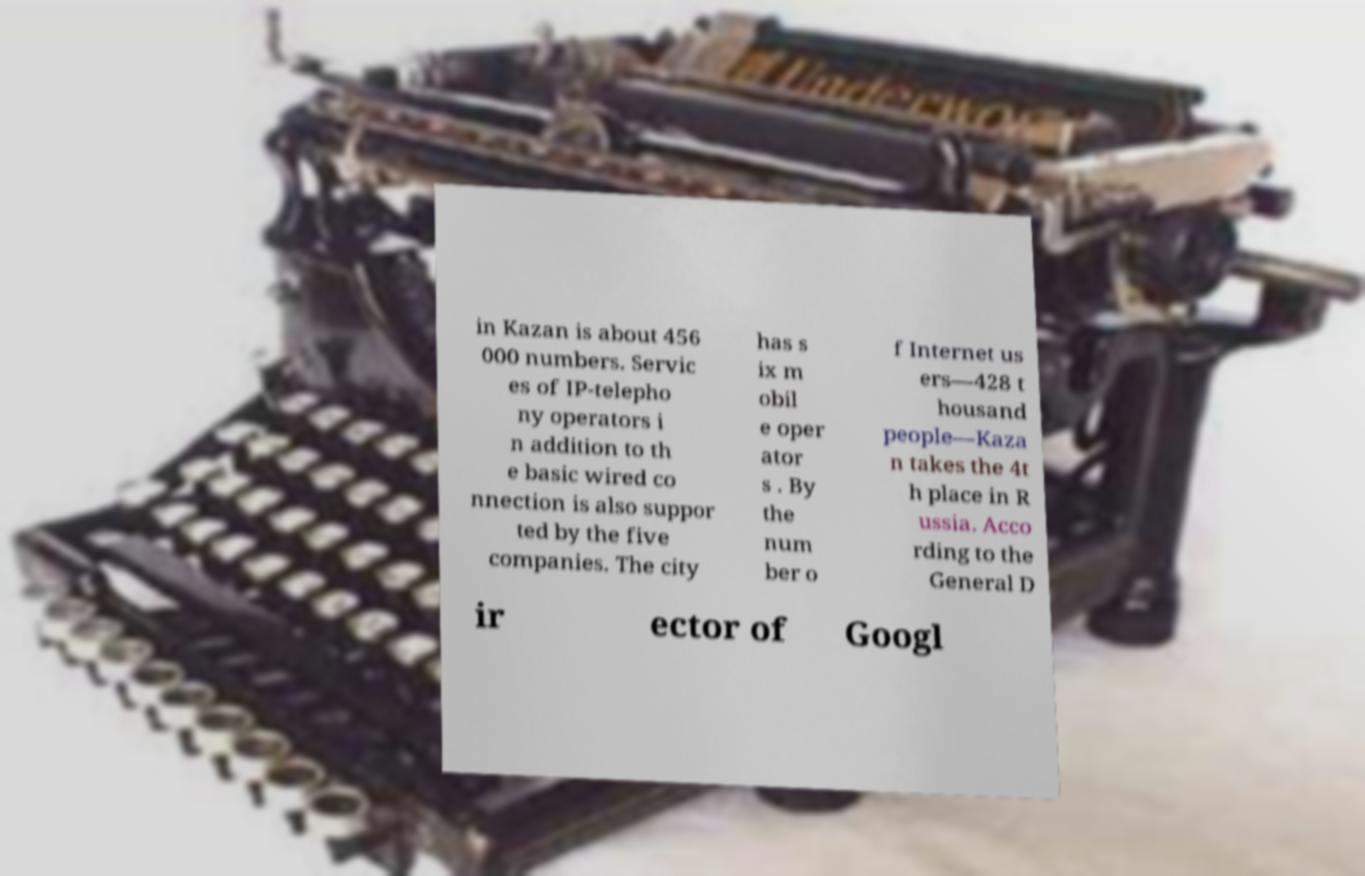For documentation purposes, I need the text within this image transcribed. Could you provide that? in Kazan is about 456 000 numbers. Servic es of IP-telepho ny operators i n addition to th e basic wired co nnection is also suppor ted by the five companies. The city has s ix m obil e oper ator s . By the num ber o f Internet us ers—428 t housand people—Kaza n takes the 4t h place in R ussia. Acco rding to the General D ir ector of Googl 